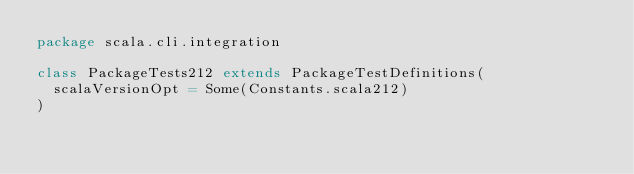Convert code to text. <code><loc_0><loc_0><loc_500><loc_500><_Scala_>package scala.cli.integration

class PackageTests212 extends PackageTestDefinitions(
  scalaVersionOpt = Some(Constants.scala212)
)
</code> 